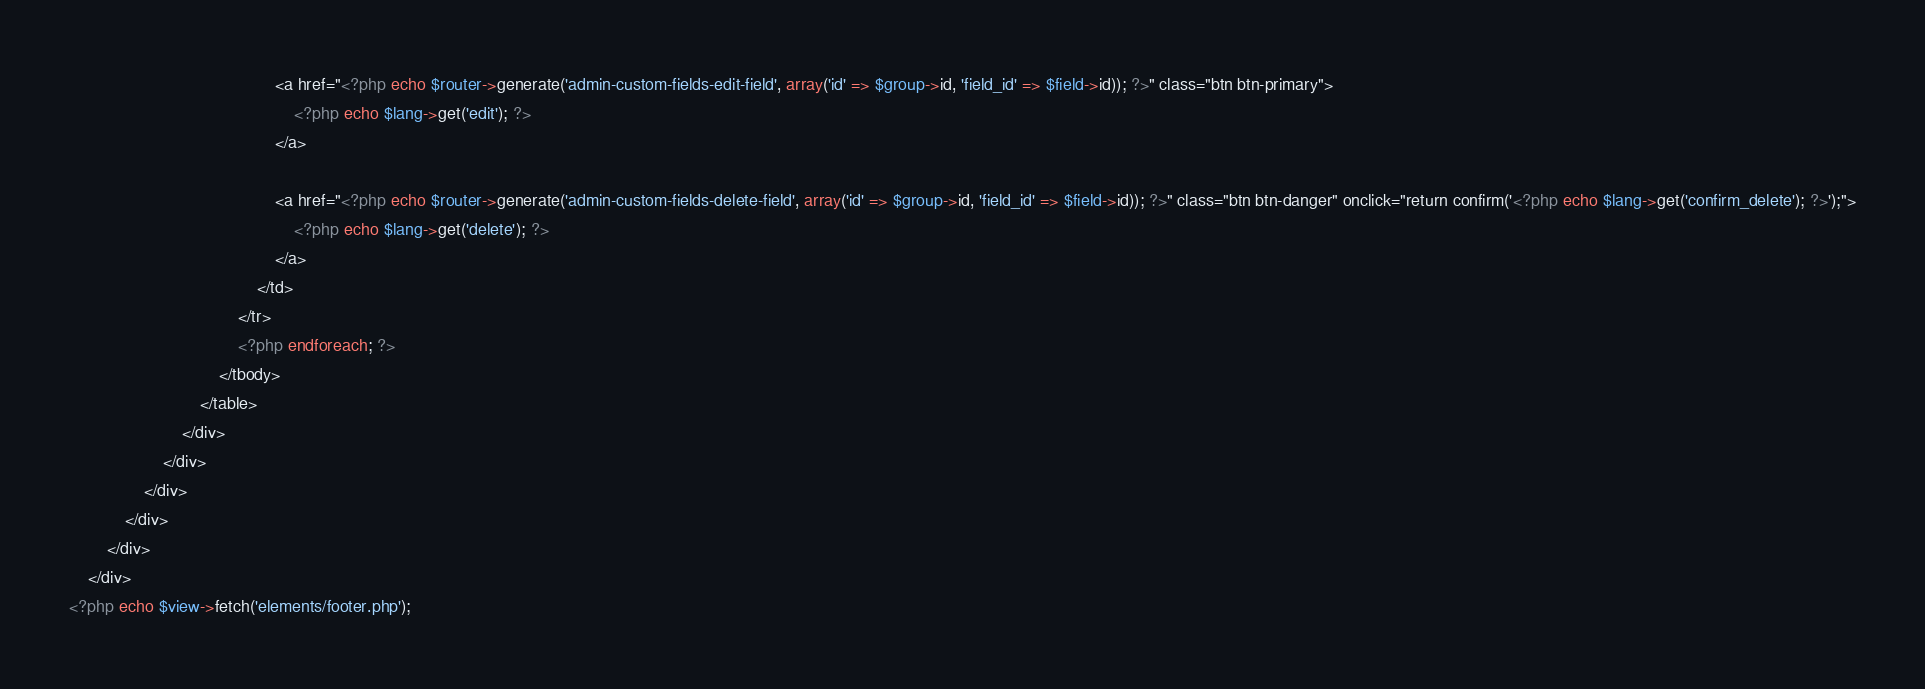<code> <loc_0><loc_0><loc_500><loc_500><_PHP_>                                            <a href="<?php echo $router->generate('admin-custom-fields-edit-field', array('id' => $group->id, 'field_id' => $field->id)); ?>" class="btn btn-primary">
                                                <?php echo $lang->get('edit'); ?>
                                            </a>

                                            <a href="<?php echo $router->generate('admin-custom-fields-delete-field', array('id' => $group->id, 'field_id' => $field->id)); ?>" class="btn btn-danger" onclick="return confirm('<?php echo $lang->get('confirm_delete'); ?>');">
                                                <?php echo $lang->get('delete'); ?>
                                            </a>
                                        </td>
                                    </tr>
                                    <?php endforeach; ?>
                                </tbody>
                            </table>
                        </div>
                    </div>
                </div>
            </div>
        </div>
    </div>
<?php echo $view->fetch('elements/footer.php');
</code> 